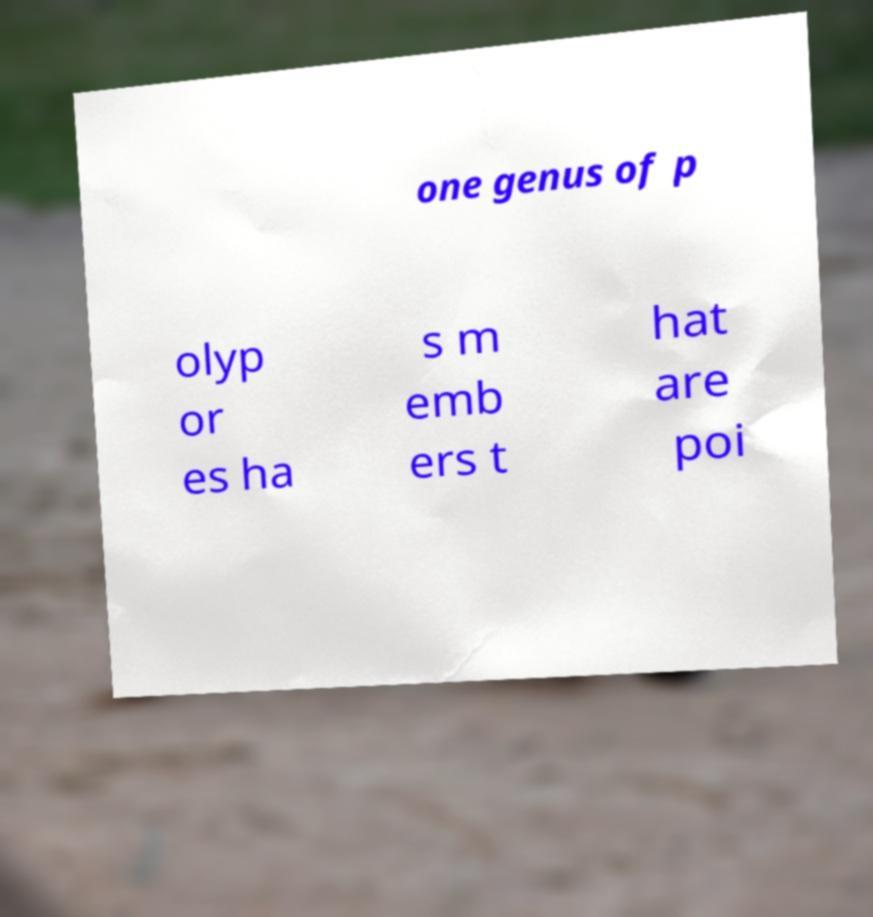For documentation purposes, I need the text within this image transcribed. Could you provide that? one genus of p olyp or es ha s m emb ers t hat are poi 